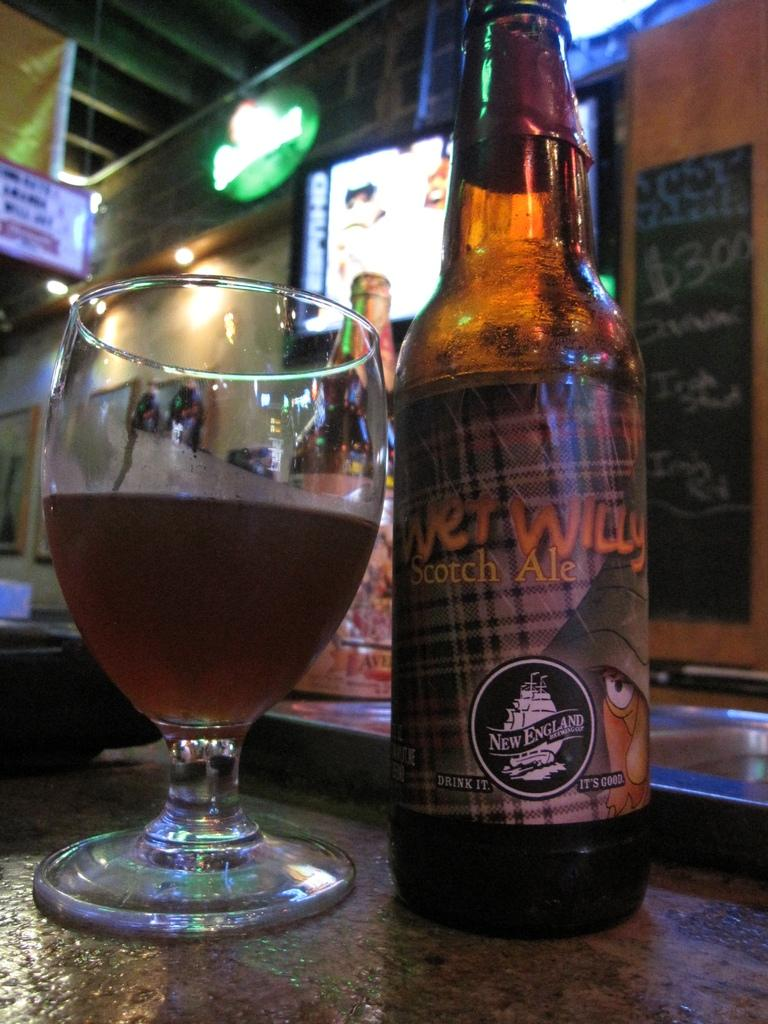<image>
Offer a succinct explanation of the picture presented. Bottle of Wet Willy Scotch Ale next to a cup of beer. 